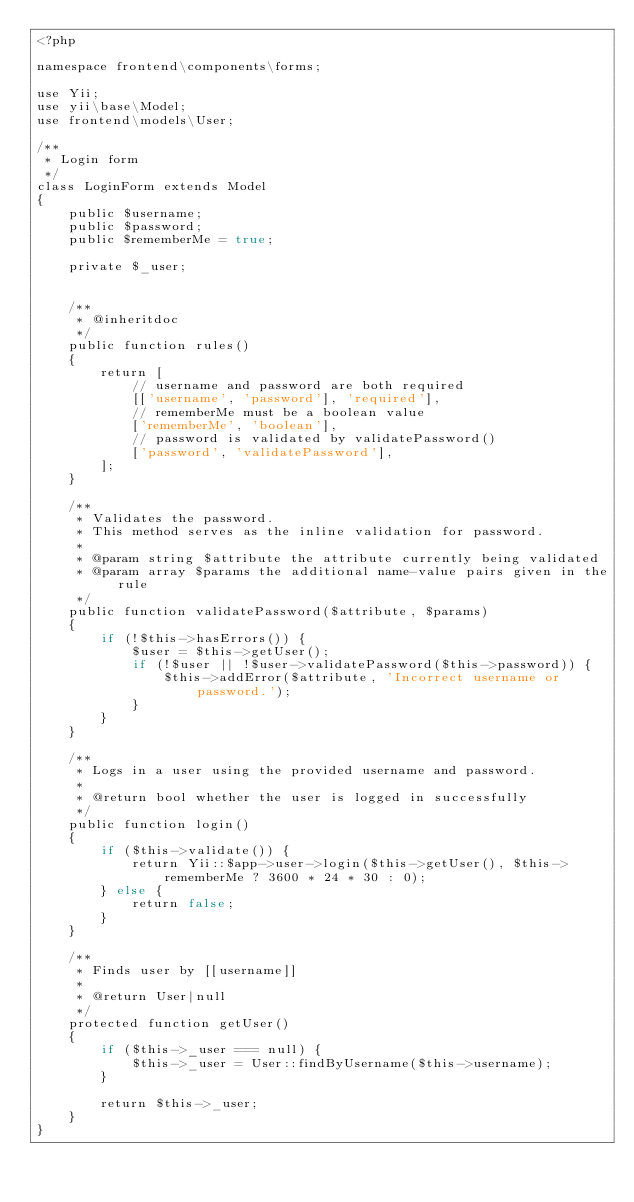Convert code to text. <code><loc_0><loc_0><loc_500><loc_500><_PHP_><?php

namespace frontend\components\forms;

use Yii;
use yii\base\Model;
use frontend\models\User;

/**
 * Login form
 */
class LoginForm extends Model
{
    public $username;
    public $password;
    public $rememberMe = true;

    private $_user;


    /**
     * @inheritdoc
     */
    public function rules()
    {
        return [
            // username and password are both required
            [['username', 'password'], 'required'],
            // rememberMe must be a boolean value
            ['rememberMe', 'boolean'],
            // password is validated by validatePassword()
            ['password', 'validatePassword'],
        ];
    }

    /**
     * Validates the password.
     * This method serves as the inline validation for password.
     *
     * @param string $attribute the attribute currently being validated
     * @param array $params the additional name-value pairs given in the rule
     */
    public function validatePassword($attribute, $params)
    {
        if (!$this->hasErrors()) {
            $user = $this->getUser();
            if (!$user || !$user->validatePassword($this->password)) {
                $this->addError($attribute, 'Incorrect username or password.');
            }
        }
    }

    /**
     * Logs in a user using the provided username and password.
     *
     * @return bool whether the user is logged in successfully
     */
    public function login()
    {
        if ($this->validate()) {
            return Yii::$app->user->login($this->getUser(), $this->rememberMe ? 3600 * 24 * 30 : 0);
        } else {
            return false;
        }
    }

    /**
     * Finds user by [[username]]
     *
     * @return User|null
     */
    protected function getUser()
    {
        if ($this->_user === null) {
            $this->_user = User::findByUsername($this->username);
        }

        return $this->_user;
    }
}
</code> 